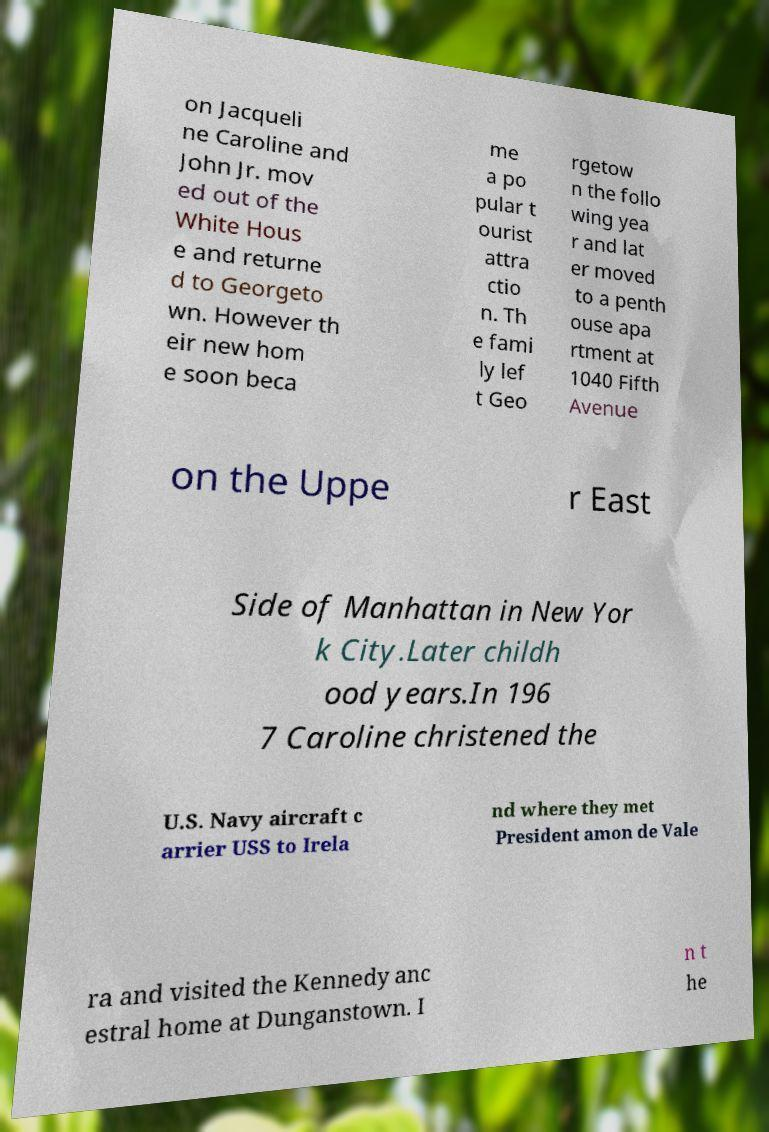I need the written content from this picture converted into text. Can you do that? on Jacqueli ne Caroline and John Jr. mov ed out of the White Hous e and returne d to Georgeto wn. However th eir new hom e soon beca me a po pular t ourist attra ctio n. Th e fami ly lef t Geo rgetow n the follo wing yea r and lat er moved to a penth ouse apa rtment at 1040 Fifth Avenue on the Uppe r East Side of Manhattan in New Yor k City.Later childh ood years.In 196 7 Caroline christened the U.S. Navy aircraft c arrier USS to Irela nd where they met President amon de Vale ra and visited the Kennedy anc estral home at Dunganstown. I n t he 